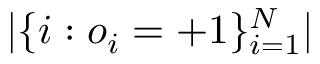<formula> <loc_0><loc_0><loc_500><loc_500>| \{ i \colon o _ { i } = + 1 \} _ { i = 1 } ^ { N } |</formula> 